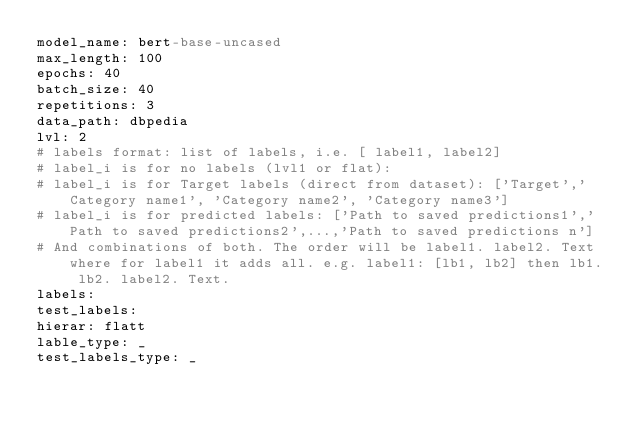Convert code to text. <code><loc_0><loc_0><loc_500><loc_500><_YAML_>model_name: bert-base-uncased
max_length: 100
epochs: 40
batch_size: 40
repetitions: 3
data_path: dbpedia
lvl: 2
# labels format: list of labels, i.e. [ label1, label2]
# label_i is for no labels (lvl1 or flat):
# label_i is for Target labels (direct from dataset): ['Target','Category name1', 'Category name2', 'Category name3']
# label_i is for predicted labels: ['Path to saved predictions1','Path to saved predictions2',...,'Path to saved predictions n']
# And combinations of both. The order will be label1. label2. Text where for label1 it adds all. e.g. label1: [lb1, lb2] then lb1. lb2. label2. Text.
labels:
test_labels:
hierar: flatt
lable_type: _
test_labels_type: _
</code> 